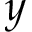Convert formula to latex. <formula><loc_0><loc_0><loc_500><loc_500>y</formula> 